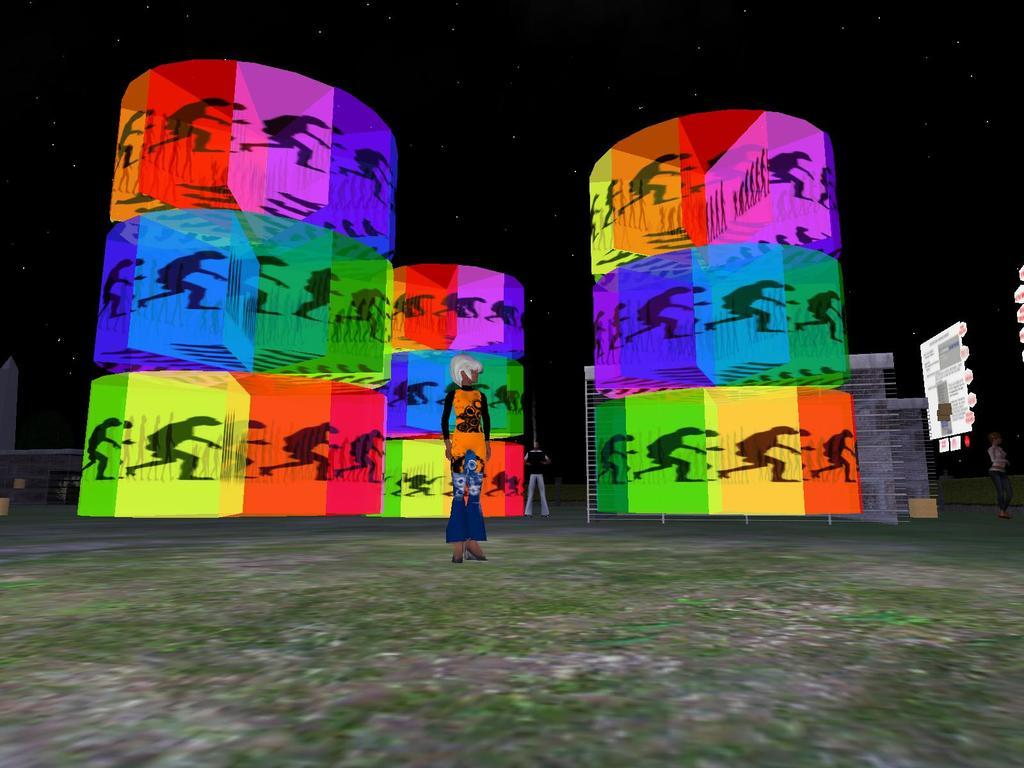What type of image is being described? The image is an animated picture. Can you describe the subjects in the image? There are people in the image. What can be observed about the colors in the image? There are colorful elements in the image. What part of the natural environment is visible in the image? The ground is visible in the image, and the sky is visible in the background. What celestial objects can be seen in the sky? There are stars visible in the sky. What type of property does the king sit on in the image? There is no church or king present in the image, so it's not possible to determine what type of property the king might be sitting on. 